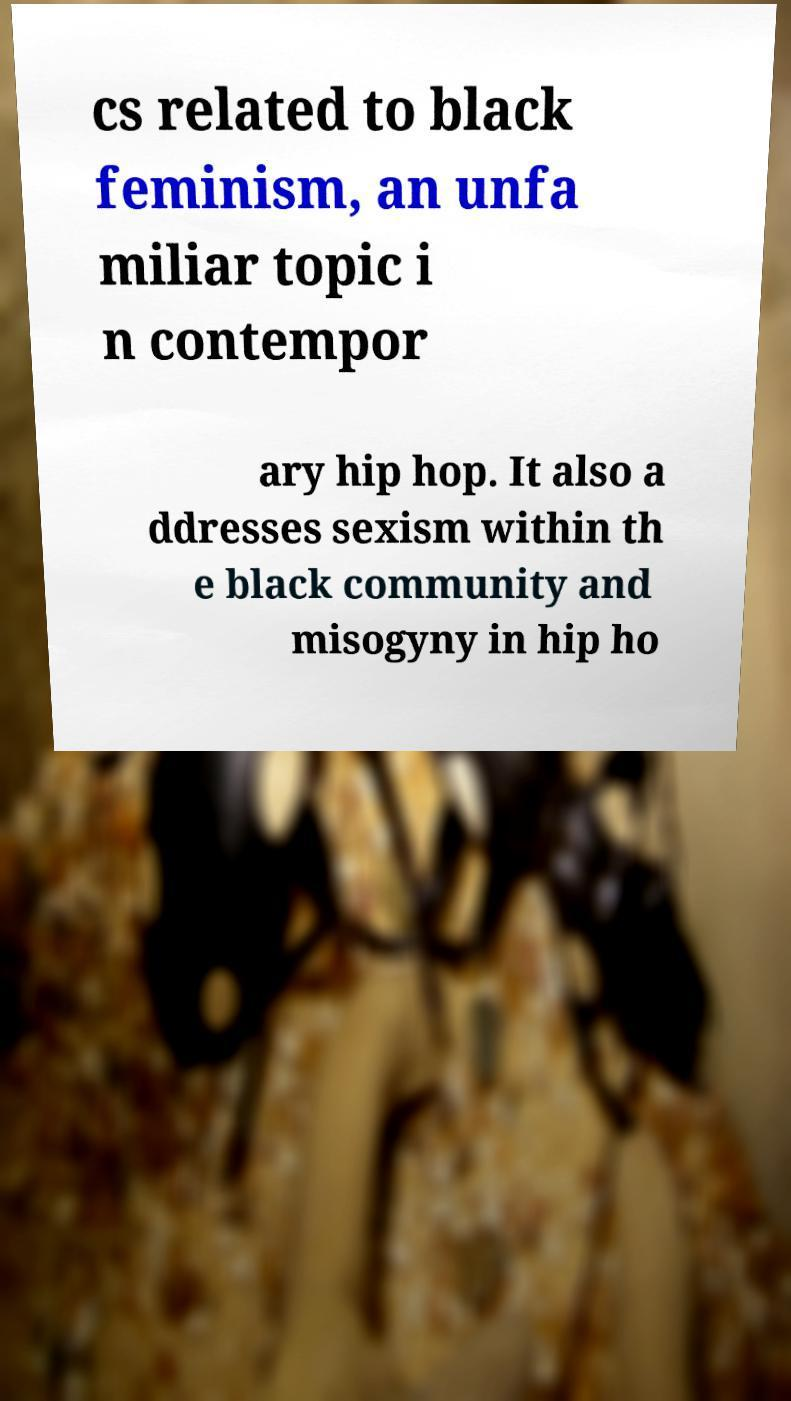Can you read and provide the text displayed in the image?This photo seems to have some interesting text. Can you extract and type it out for me? cs related to black feminism, an unfa miliar topic i n contempor ary hip hop. It also a ddresses sexism within th e black community and misogyny in hip ho 